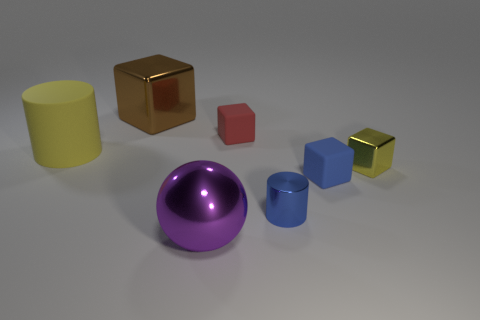Subtract 1 cubes. How many cubes are left? 3 Add 1 brown objects. How many objects exist? 8 Subtract all cylinders. How many objects are left? 5 Add 4 big green matte cylinders. How many big green matte cylinders exist? 4 Subtract 0 blue spheres. How many objects are left? 7 Subtract all tiny blue rubber objects. Subtract all small blue matte objects. How many objects are left? 5 Add 2 rubber blocks. How many rubber blocks are left? 4 